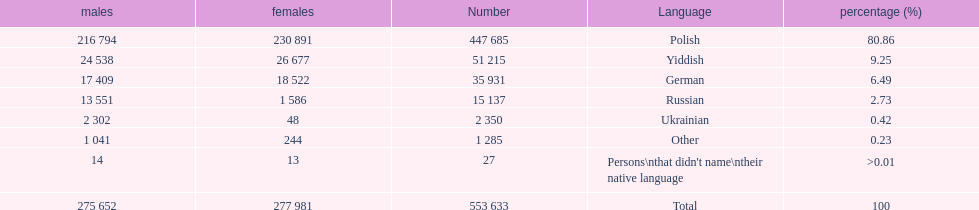Can you give me this table as a dict? {'header': ['males', 'females', 'Number', 'Language', 'percentage (%)'], 'rows': [['216 794', '230 891', '447 685', 'Polish', '80.86'], ['24 538', '26 677', '51 215', 'Yiddish', '9.25'], ['17 409', '18 522', '35 931', 'German', '6.49'], ['13 551', '1 586', '15 137', 'Russian', '2.73'], ['2 302', '48', '2 350', 'Ukrainian', '0.42'], ['1 041', '244', '1 285', 'Other', '0.23'], ['14', '13', '27', "Persons\\nthat didn't name\\ntheir native language", '>0.01'], ['275 652', '277 981', '553 633', 'Total', '100']]} How many people didn't name their native language? 27. 